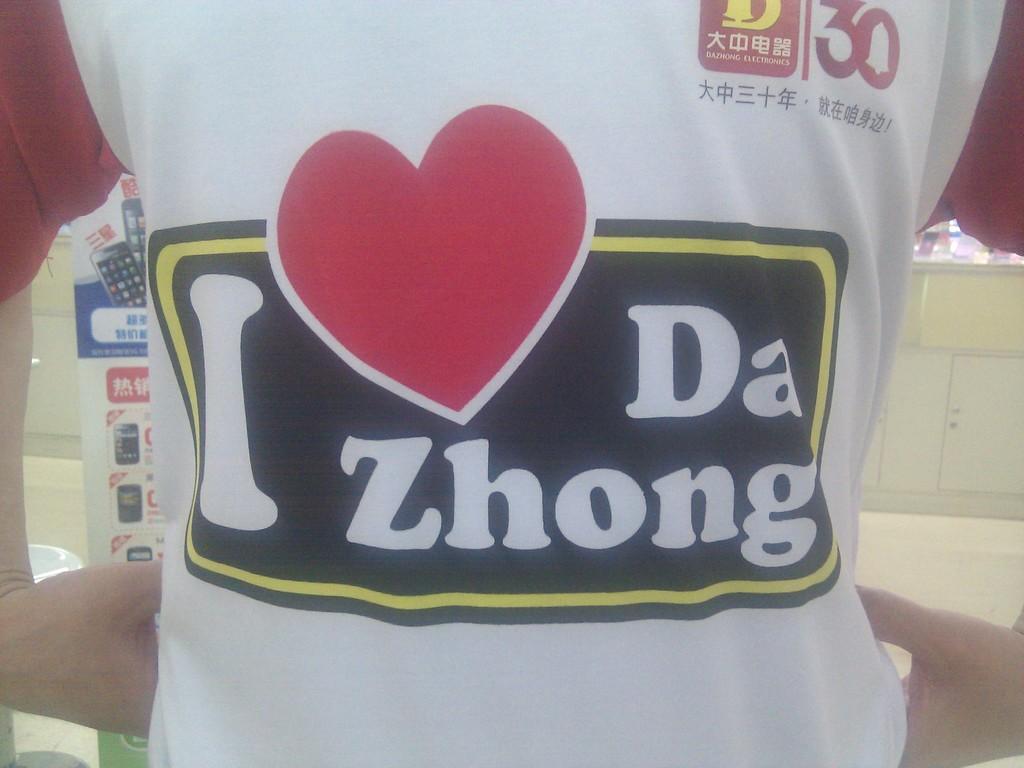What does that shirt say?
Make the answer very short. I love da zhong. What number is on the top right of the shirt?
Your answer should be very brief. 30. 